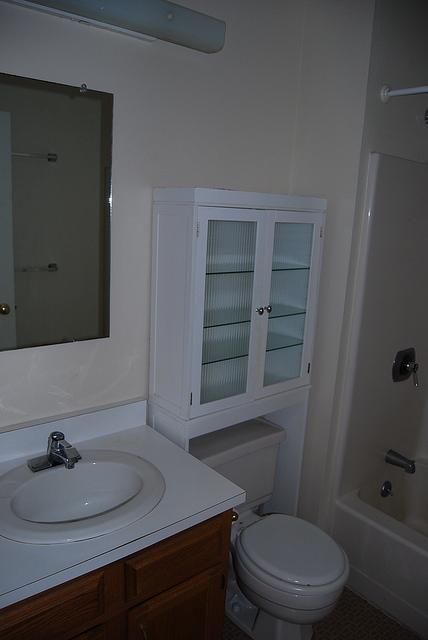How many towels are on the rack above the toilet?
Give a very brief answer. 0. How many shelves are in the cabinet with the glass doors?
Give a very brief answer. 3. How many sinks are there?
Give a very brief answer. 1. How many toilets are visible?
Give a very brief answer. 1. How many blonde people are there?
Give a very brief answer. 0. 